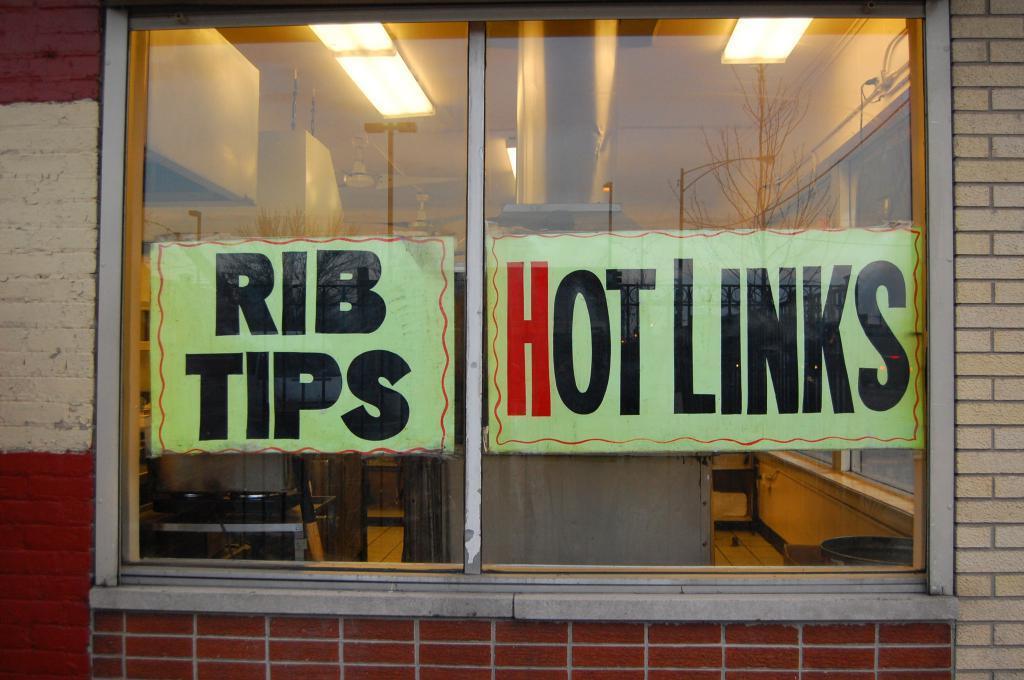How would you summarize this image in a sentence or two? In this image there is a glass window in the middle. There are labels on the window. At the top there are lights. There is a wall beside the window. 